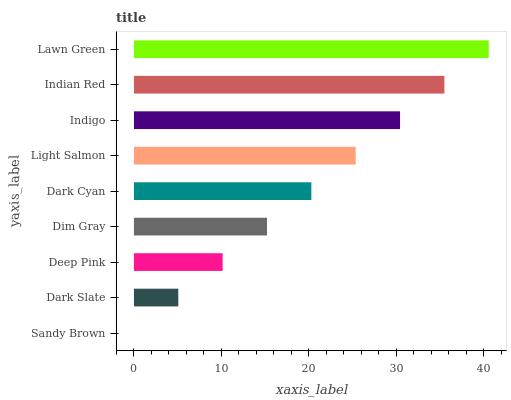Is Sandy Brown the minimum?
Answer yes or no. Yes. Is Lawn Green the maximum?
Answer yes or no. Yes. Is Dark Slate the minimum?
Answer yes or no. No. Is Dark Slate the maximum?
Answer yes or no. No. Is Dark Slate greater than Sandy Brown?
Answer yes or no. Yes. Is Sandy Brown less than Dark Slate?
Answer yes or no. Yes. Is Sandy Brown greater than Dark Slate?
Answer yes or no. No. Is Dark Slate less than Sandy Brown?
Answer yes or no. No. Is Dark Cyan the high median?
Answer yes or no. Yes. Is Dark Cyan the low median?
Answer yes or no. Yes. Is Deep Pink the high median?
Answer yes or no. No. Is Indigo the low median?
Answer yes or no. No. 